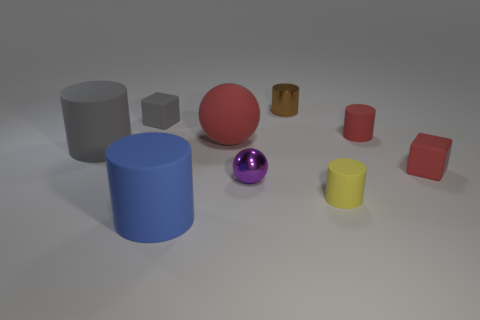Subtract all tiny red cylinders. How many cylinders are left? 4 Subtract all gray cylinders. How many cylinders are left? 4 Add 1 blocks. How many objects exist? 10 Subtract 1 balls. How many balls are left? 1 Subtract all blocks. How many objects are left? 7 Add 2 large things. How many large things exist? 5 Subtract 0 blue balls. How many objects are left? 9 Subtract all purple balls. Subtract all gray cylinders. How many balls are left? 1 Subtract all purple spheres. How many gray blocks are left? 1 Subtract all tiny rubber cubes. Subtract all big rubber cylinders. How many objects are left? 5 